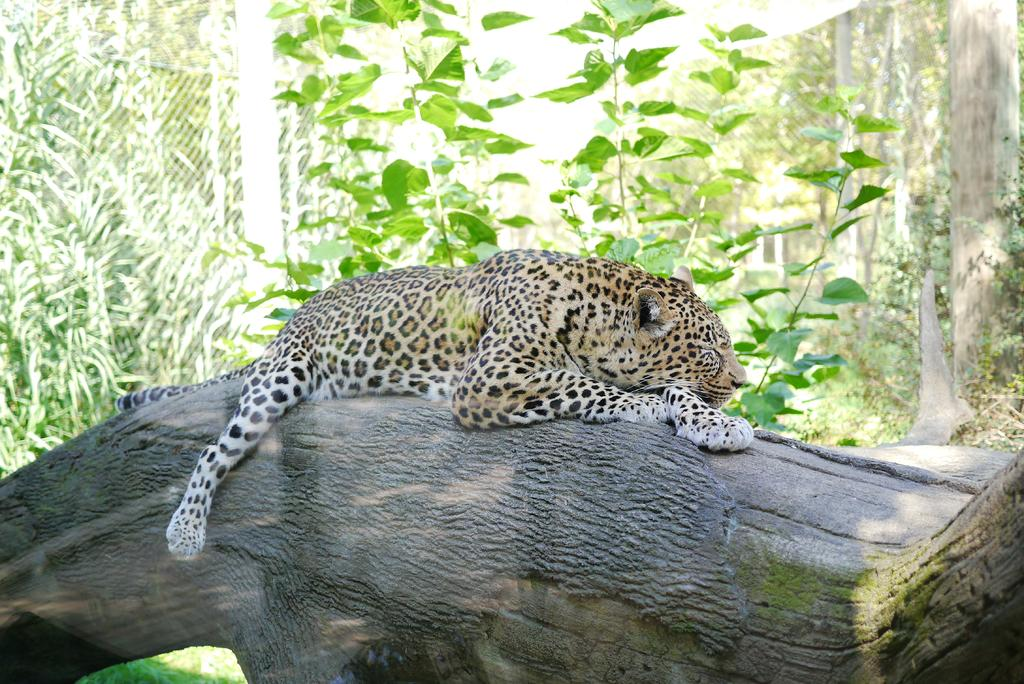What is the main subject of the image? The main subject of the image is a tree trunk. Is there any animal on the tree trunk? Yes, a tiger is present on the tree trunk. What can be seen in the background of the image? There are tall trees in the background of the image. How many tomatoes are hanging from the tree trunk in the image? There are no tomatoes present in the image; it features a tree trunk with a tiger on it. Can you see any rabbits hiding behind the tall trees in the background? There are no rabbits visible in the image; it only features a tree trunk with a tiger and tall trees in the background. 